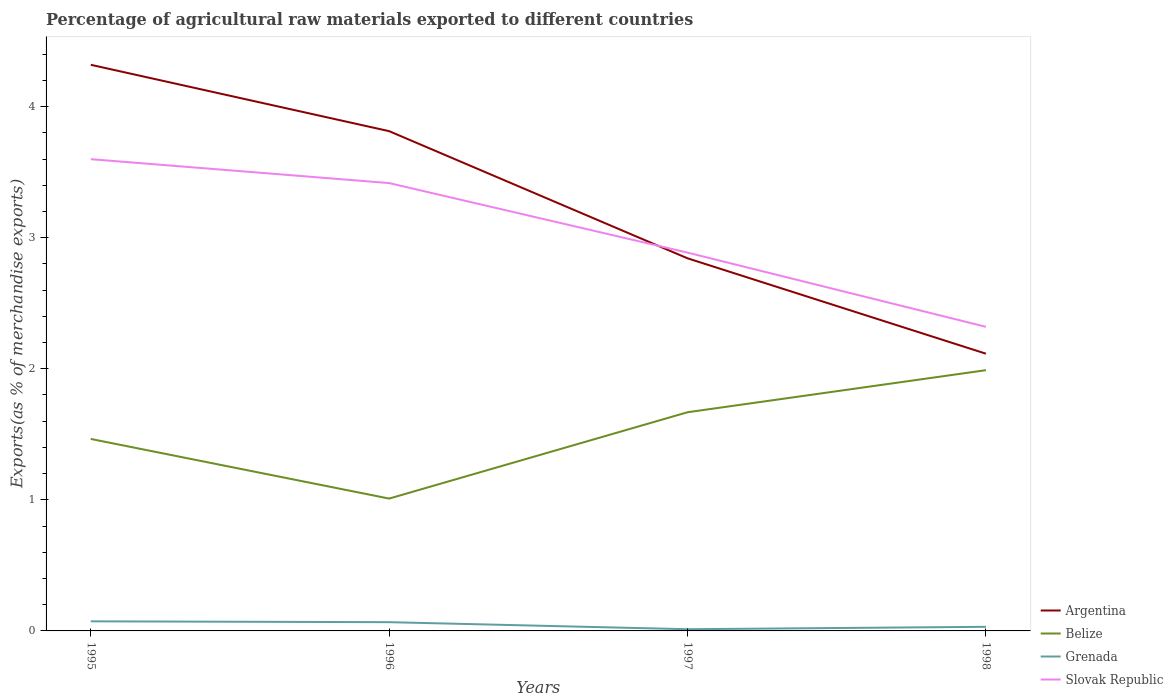How many different coloured lines are there?
Give a very brief answer. 4. Is the number of lines equal to the number of legend labels?
Your answer should be compact. Yes. Across all years, what is the maximum percentage of exports to different countries in Grenada?
Your answer should be compact. 0.01. What is the total percentage of exports to different countries in Belize in the graph?
Your answer should be compact. -0.52. What is the difference between the highest and the second highest percentage of exports to different countries in Argentina?
Your response must be concise. 2.2. What is the difference between the highest and the lowest percentage of exports to different countries in Argentina?
Keep it short and to the point. 2. Is the percentage of exports to different countries in Slovak Republic strictly greater than the percentage of exports to different countries in Argentina over the years?
Make the answer very short. No. How many lines are there?
Make the answer very short. 4. What is the difference between two consecutive major ticks on the Y-axis?
Provide a succinct answer. 1. Does the graph contain grids?
Ensure brevity in your answer.  No. How many legend labels are there?
Offer a terse response. 4. What is the title of the graph?
Make the answer very short. Percentage of agricultural raw materials exported to different countries. What is the label or title of the Y-axis?
Provide a short and direct response. Exports(as % of merchandise exports). What is the Exports(as % of merchandise exports) of Argentina in 1995?
Make the answer very short. 4.32. What is the Exports(as % of merchandise exports) of Belize in 1995?
Your answer should be compact. 1.46. What is the Exports(as % of merchandise exports) in Grenada in 1995?
Offer a terse response. 0.07. What is the Exports(as % of merchandise exports) of Slovak Republic in 1995?
Ensure brevity in your answer.  3.6. What is the Exports(as % of merchandise exports) in Argentina in 1996?
Offer a very short reply. 3.81. What is the Exports(as % of merchandise exports) of Belize in 1996?
Offer a very short reply. 1.01. What is the Exports(as % of merchandise exports) in Grenada in 1996?
Your response must be concise. 0.07. What is the Exports(as % of merchandise exports) of Slovak Republic in 1996?
Ensure brevity in your answer.  3.42. What is the Exports(as % of merchandise exports) in Argentina in 1997?
Offer a terse response. 2.84. What is the Exports(as % of merchandise exports) of Belize in 1997?
Your response must be concise. 1.67. What is the Exports(as % of merchandise exports) of Grenada in 1997?
Provide a succinct answer. 0.01. What is the Exports(as % of merchandise exports) in Slovak Republic in 1997?
Keep it short and to the point. 2.89. What is the Exports(as % of merchandise exports) of Argentina in 1998?
Offer a terse response. 2.11. What is the Exports(as % of merchandise exports) in Belize in 1998?
Give a very brief answer. 1.99. What is the Exports(as % of merchandise exports) in Grenada in 1998?
Provide a succinct answer. 0.03. What is the Exports(as % of merchandise exports) of Slovak Republic in 1998?
Keep it short and to the point. 2.32. Across all years, what is the maximum Exports(as % of merchandise exports) in Argentina?
Your answer should be very brief. 4.32. Across all years, what is the maximum Exports(as % of merchandise exports) in Belize?
Ensure brevity in your answer.  1.99. Across all years, what is the maximum Exports(as % of merchandise exports) of Grenada?
Provide a short and direct response. 0.07. Across all years, what is the maximum Exports(as % of merchandise exports) of Slovak Republic?
Your answer should be very brief. 3.6. Across all years, what is the minimum Exports(as % of merchandise exports) of Argentina?
Keep it short and to the point. 2.11. Across all years, what is the minimum Exports(as % of merchandise exports) in Belize?
Your answer should be very brief. 1.01. Across all years, what is the minimum Exports(as % of merchandise exports) of Grenada?
Ensure brevity in your answer.  0.01. Across all years, what is the minimum Exports(as % of merchandise exports) in Slovak Republic?
Your answer should be compact. 2.32. What is the total Exports(as % of merchandise exports) in Argentina in the graph?
Make the answer very short. 13.09. What is the total Exports(as % of merchandise exports) in Belize in the graph?
Your answer should be compact. 6.13. What is the total Exports(as % of merchandise exports) in Grenada in the graph?
Offer a terse response. 0.18. What is the total Exports(as % of merchandise exports) in Slovak Republic in the graph?
Your answer should be compact. 12.22. What is the difference between the Exports(as % of merchandise exports) in Argentina in 1995 and that in 1996?
Keep it short and to the point. 0.51. What is the difference between the Exports(as % of merchandise exports) in Belize in 1995 and that in 1996?
Make the answer very short. 0.45. What is the difference between the Exports(as % of merchandise exports) of Grenada in 1995 and that in 1996?
Give a very brief answer. 0.01. What is the difference between the Exports(as % of merchandise exports) of Slovak Republic in 1995 and that in 1996?
Keep it short and to the point. 0.18. What is the difference between the Exports(as % of merchandise exports) in Argentina in 1995 and that in 1997?
Ensure brevity in your answer.  1.48. What is the difference between the Exports(as % of merchandise exports) of Belize in 1995 and that in 1997?
Offer a terse response. -0.2. What is the difference between the Exports(as % of merchandise exports) of Grenada in 1995 and that in 1997?
Your answer should be compact. 0.06. What is the difference between the Exports(as % of merchandise exports) in Slovak Republic in 1995 and that in 1997?
Provide a short and direct response. 0.71. What is the difference between the Exports(as % of merchandise exports) of Argentina in 1995 and that in 1998?
Ensure brevity in your answer.  2.2. What is the difference between the Exports(as % of merchandise exports) in Belize in 1995 and that in 1998?
Make the answer very short. -0.52. What is the difference between the Exports(as % of merchandise exports) of Grenada in 1995 and that in 1998?
Provide a succinct answer. 0.04. What is the difference between the Exports(as % of merchandise exports) of Slovak Republic in 1995 and that in 1998?
Offer a terse response. 1.28. What is the difference between the Exports(as % of merchandise exports) of Belize in 1996 and that in 1997?
Give a very brief answer. -0.66. What is the difference between the Exports(as % of merchandise exports) of Grenada in 1996 and that in 1997?
Your answer should be compact. 0.05. What is the difference between the Exports(as % of merchandise exports) in Slovak Republic in 1996 and that in 1997?
Give a very brief answer. 0.53. What is the difference between the Exports(as % of merchandise exports) of Argentina in 1996 and that in 1998?
Keep it short and to the point. 1.7. What is the difference between the Exports(as % of merchandise exports) of Belize in 1996 and that in 1998?
Ensure brevity in your answer.  -0.98. What is the difference between the Exports(as % of merchandise exports) of Grenada in 1996 and that in 1998?
Make the answer very short. 0.04. What is the difference between the Exports(as % of merchandise exports) in Slovak Republic in 1996 and that in 1998?
Offer a very short reply. 1.1. What is the difference between the Exports(as % of merchandise exports) in Argentina in 1997 and that in 1998?
Your response must be concise. 0.73. What is the difference between the Exports(as % of merchandise exports) of Belize in 1997 and that in 1998?
Give a very brief answer. -0.32. What is the difference between the Exports(as % of merchandise exports) in Grenada in 1997 and that in 1998?
Your answer should be compact. -0.02. What is the difference between the Exports(as % of merchandise exports) of Slovak Republic in 1997 and that in 1998?
Provide a short and direct response. 0.57. What is the difference between the Exports(as % of merchandise exports) in Argentina in 1995 and the Exports(as % of merchandise exports) in Belize in 1996?
Offer a very short reply. 3.31. What is the difference between the Exports(as % of merchandise exports) in Argentina in 1995 and the Exports(as % of merchandise exports) in Grenada in 1996?
Make the answer very short. 4.25. What is the difference between the Exports(as % of merchandise exports) of Argentina in 1995 and the Exports(as % of merchandise exports) of Slovak Republic in 1996?
Make the answer very short. 0.9. What is the difference between the Exports(as % of merchandise exports) of Belize in 1995 and the Exports(as % of merchandise exports) of Grenada in 1996?
Make the answer very short. 1.4. What is the difference between the Exports(as % of merchandise exports) of Belize in 1995 and the Exports(as % of merchandise exports) of Slovak Republic in 1996?
Your response must be concise. -1.95. What is the difference between the Exports(as % of merchandise exports) in Grenada in 1995 and the Exports(as % of merchandise exports) in Slovak Republic in 1996?
Your response must be concise. -3.34. What is the difference between the Exports(as % of merchandise exports) in Argentina in 1995 and the Exports(as % of merchandise exports) in Belize in 1997?
Provide a succinct answer. 2.65. What is the difference between the Exports(as % of merchandise exports) in Argentina in 1995 and the Exports(as % of merchandise exports) in Grenada in 1997?
Your answer should be very brief. 4.31. What is the difference between the Exports(as % of merchandise exports) in Argentina in 1995 and the Exports(as % of merchandise exports) in Slovak Republic in 1997?
Ensure brevity in your answer.  1.43. What is the difference between the Exports(as % of merchandise exports) in Belize in 1995 and the Exports(as % of merchandise exports) in Grenada in 1997?
Offer a terse response. 1.45. What is the difference between the Exports(as % of merchandise exports) in Belize in 1995 and the Exports(as % of merchandise exports) in Slovak Republic in 1997?
Provide a succinct answer. -1.42. What is the difference between the Exports(as % of merchandise exports) of Grenada in 1995 and the Exports(as % of merchandise exports) of Slovak Republic in 1997?
Your answer should be very brief. -2.81. What is the difference between the Exports(as % of merchandise exports) in Argentina in 1995 and the Exports(as % of merchandise exports) in Belize in 1998?
Your answer should be compact. 2.33. What is the difference between the Exports(as % of merchandise exports) of Argentina in 1995 and the Exports(as % of merchandise exports) of Grenada in 1998?
Offer a terse response. 4.29. What is the difference between the Exports(as % of merchandise exports) in Argentina in 1995 and the Exports(as % of merchandise exports) in Slovak Republic in 1998?
Your answer should be compact. 2. What is the difference between the Exports(as % of merchandise exports) in Belize in 1995 and the Exports(as % of merchandise exports) in Grenada in 1998?
Provide a succinct answer. 1.43. What is the difference between the Exports(as % of merchandise exports) of Belize in 1995 and the Exports(as % of merchandise exports) of Slovak Republic in 1998?
Provide a succinct answer. -0.86. What is the difference between the Exports(as % of merchandise exports) of Grenada in 1995 and the Exports(as % of merchandise exports) of Slovak Republic in 1998?
Provide a short and direct response. -2.25. What is the difference between the Exports(as % of merchandise exports) in Argentina in 1996 and the Exports(as % of merchandise exports) in Belize in 1997?
Offer a very short reply. 2.14. What is the difference between the Exports(as % of merchandise exports) in Argentina in 1996 and the Exports(as % of merchandise exports) in Grenada in 1997?
Give a very brief answer. 3.8. What is the difference between the Exports(as % of merchandise exports) of Argentina in 1996 and the Exports(as % of merchandise exports) of Slovak Republic in 1997?
Your response must be concise. 0.93. What is the difference between the Exports(as % of merchandise exports) of Belize in 1996 and the Exports(as % of merchandise exports) of Grenada in 1997?
Provide a succinct answer. 1. What is the difference between the Exports(as % of merchandise exports) of Belize in 1996 and the Exports(as % of merchandise exports) of Slovak Republic in 1997?
Keep it short and to the point. -1.88. What is the difference between the Exports(as % of merchandise exports) in Grenada in 1996 and the Exports(as % of merchandise exports) in Slovak Republic in 1997?
Give a very brief answer. -2.82. What is the difference between the Exports(as % of merchandise exports) in Argentina in 1996 and the Exports(as % of merchandise exports) in Belize in 1998?
Keep it short and to the point. 1.82. What is the difference between the Exports(as % of merchandise exports) in Argentina in 1996 and the Exports(as % of merchandise exports) in Grenada in 1998?
Make the answer very short. 3.78. What is the difference between the Exports(as % of merchandise exports) in Argentina in 1996 and the Exports(as % of merchandise exports) in Slovak Republic in 1998?
Ensure brevity in your answer.  1.49. What is the difference between the Exports(as % of merchandise exports) in Belize in 1996 and the Exports(as % of merchandise exports) in Grenada in 1998?
Your answer should be compact. 0.98. What is the difference between the Exports(as % of merchandise exports) in Belize in 1996 and the Exports(as % of merchandise exports) in Slovak Republic in 1998?
Give a very brief answer. -1.31. What is the difference between the Exports(as % of merchandise exports) in Grenada in 1996 and the Exports(as % of merchandise exports) in Slovak Republic in 1998?
Keep it short and to the point. -2.25. What is the difference between the Exports(as % of merchandise exports) in Argentina in 1997 and the Exports(as % of merchandise exports) in Belize in 1998?
Make the answer very short. 0.85. What is the difference between the Exports(as % of merchandise exports) in Argentina in 1997 and the Exports(as % of merchandise exports) in Grenada in 1998?
Provide a short and direct response. 2.81. What is the difference between the Exports(as % of merchandise exports) in Argentina in 1997 and the Exports(as % of merchandise exports) in Slovak Republic in 1998?
Provide a succinct answer. 0.52. What is the difference between the Exports(as % of merchandise exports) in Belize in 1997 and the Exports(as % of merchandise exports) in Grenada in 1998?
Offer a terse response. 1.64. What is the difference between the Exports(as % of merchandise exports) of Belize in 1997 and the Exports(as % of merchandise exports) of Slovak Republic in 1998?
Your answer should be very brief. -0.65. What is the difference between the Exports(as % of merchandise exports) of Grenada in 1997 and the Exports(as % of merchandise exports) of Slovak Republic in 1998?
Offer a terse response. -2.31. What is the average Exports(as % of merchandise exports) of Argentina per year?
Offer a terse response. 3.27. What is the average Exports(as % of merchandise exports) in Belize per year?
Ensure brevity in your answer.  1.53. What is the average Exports(as % of merchandise exports) of Grenada per year?
Your answer should be very brief. 0.05. What is the average Exports(as % of merchandise exports) of Slovak Republic per year?
Keep it short and to the point. 3.06. In the year 1995, what is the difference between the Exports(as % of merchandise exports) of Argentina and Exports(as % of merchandise exports) of Belize?
Give a very brief answer. 2.85. In the year 1995, what is the difference between the Exports(as % of merchandise exports) of Argentina and Exports(as % of merchandise exports) of Grenada?
Make the answer very short. 4.25. In the year 1995, what is the difference between the Exports(as % of merchandise exports) in Argentina and Exports(as % of merchandise exports) in Slovak Republic?
Make the answer very short. 0.72. In the year 1995, what is the difference between the Exports(as % of merchandise exports) in Belize and Exports(as % of merchandise exports) in Grenada?
Your response must be concise. 1.39. In the year 1995, what is the difference between the Exports(as % of merchandise exports) of Belize and Exports(as % of merchandise exports) of Slovak Republic?
Offer a terse response. -2.13. In the year 1995, what is the difference between the Exports(as % of merchandise exports) of Grenada and Exports(as % of merchandise exports) of Slovak Republic?
Provide a succinct answer. -3.53. In the year 1996, what is the difference between the Exports(as % of merchandise exports) of Argentina and Exports(as % of merchandise exports) of Belize?
Ensure brevity in your answer.  2.8. In the year 1996, what is the difference between the Exports(as % of merchandise exports) in Argentina and Exports(as % of merchandise exports) in Grenada?
Offer a very short reply. 3.75. In the year 1996, what is the difference between the Exports(as % of merchandise exports) in Argentina and Exports(as % of merchandise exports) in Slovak Republic?
Your answer should be compact. 0.4. In the year 1996, what is the difference between the Exports(as % of merchandise exports) in Belize and Exports(as % of merchandise exports) in Grenada?
Your answer should be compact. 0.94. In the year 1996, what is the difference between the Exports(as % of merchandise exports) in Belize and Exports(as % of merchandise exports) in Slovak Republic?
Your answer should be very brief. -2.41. In the year 1996, what is the difference between the Exports(as % of merchandise exports) of Grenada and Exports(as % of merchandise exports) of Slovak Republic?
Offer a terse response. -3.35. In the year 1997, what is the difference between the Exports(as % of merchandise exports) in Argentina and Exports(as % of merchandise exports) in Belize?
Offer a terse response. 1.17. In the year 1997, what is the difference between the Exports(as % of merchandise exports) of Argentina and Exports(as % of merchandise exports) of Grenada?
Your response must be concise. 2.83. In the year 1997, what is the difference between the Exports(as % of merchandise exports) of Argentina and Exports(as % of merchandise exports) of Slovak Republic?
Your answer should be very brief. -0.04. In the year 1997, what is the difference between the Exports(as % of merchandise exports) of Belize and Exports(as % of merchandise exports) of Grenada?
Offer a very short reply. 1.66. In the year 1997, what is the difference between the Exports(as % of merchandise exports) in Belize and Exports(as % of merchandise exports) in Slovak Republic?
Provide a succinct answer. -1.22. In the year 1997, what is the difference between the Exports(as % of merchandise exports) in Grenada and Exports(as % of merchandise exports) in Slovak Republic?
Give a very brief answer. -2.87. In the year 1998, what is the difference between the Exports(as % of merchandise exports) of Argentina and Exports(as % of merchandise exports) of Belize?
Your answer should be very brief. 0.13. In the year 1998, what is the difference between the Exports(as % of merchandise exports) in Argentina and Exports(as % of merchandise exports) in Grenada?
Make the answer very short. 2.08. In the year 1998, what is the difference between the Exports(as % of merchandise exports) in Argentina and Exports(as % of merchandise exports) in Slovak Republic?
Your response must be concise. -0.2. In the year 1998, what is the difference between the Exports(as % of merchandise exports) of Belize and Exports(as % of merchandise exports) of Grenada?
Provide a short and direct response. 1.96. In the year 1998, what is the difference between the Exports(as % of merchandise exports) in Belize and Exports(as % of merchandise exports) in Slovak Republic?
Make the answer very short. -0.33. In the year 1998, what is the difference between the Exports(as % of merchandise exports) in Grenada and Exports(as % of merchandise exports) in Slovak Republic?
Your response must be concise. -2.29. What is the ratio of the Exports(as % of merchandise exports) in Argentina in 1995 to that in 1996?
Your answer should be compact. 1.13. What is the ratio of the Exports(as % of merchandise exports) in Belize in 1995 to that in 1996?
Offer a very short reply. 1.45. What is the ratio of the Exports(as % of merchandise exports) in Grenada in 1995 to that in 1996?
Your response must be concise. 1.1. What is the ratio of the Exports(as % of merchandise exports) in Slovak Republic in 1995 to that in 1996?
Your answer should be very brief. 1.05. What is the ratio of the Exports(as % of merchandise exports) of Argentina in 1995 to that in 1997?
Your answer should be very brief. 1.52. What is the ratio of the Exports(as % of merchandise exports) in Belize in 1995 to that in 1997?
Provide a succinct answer. 0.88. What is the ratio of the Exports(as % of merchandise exports) of Grenada in 1995 to that in 1997?
Make the answer very short. 5.61. What is the ratio of the Exports(as % of merchandise exports) in Slovak Republic in 1995 to that in 1997?
Your answer should be very brief. 1.25. What is the ratio of the Exports(as % of merchandise exports) of Argentina in 1995 to that in 1998?
Offer a very short reply. 2.04. What is the ratio of the Exports(as % of merchandise exports) in Belize in 1995 to that in 1998?
Give a very brief answer. 0.74. What is the ratio of the Exports(as % of merchandise exports) of Grenada in 1995 to that in 1998?
Provide a succinct answer. 2.33. What is the ratio of the Exports(as % of merchandise exports) of Slovak Republic in 1995 to that in 1998?
Your response must be concise. 1.55. What is the ratio of the Exports(as % of merchandise exports) in Argentina in 1996 to that in 1997?
Give a very brief answer. 1.34. What is the ratio of the Exports(as % of merchandise exports) of Belize in 1996 to that in 1997?
Your response must be concise. 0.61. What is the ratio of the Exports(as % of merchandise exports) of Grenada in 1996 to that in 1997?
Your answer should be compact. 5.12. What is the ratio of the Exports(as % of merchandise exports) of Slovak Republic in 1996 to that in 1997?
Your answer should be very brief. 1.18. What is the ratio of the Exports(as % of merchandise exports) of Argentina in 1996 to that in 1998?
Provide a short and direct response. 1.8. What is the ratio of the Exports(as % of merchandise exports) in Belize in 1996 to that in 1998?
Provide a succinct answer. 0.51. What is the ratio of the Exports(as % of merchandise exports) in Grenada in 1996 to that in 1998?
Your response must be concise. 2.13. What is the ratio of the Exports(as % of merchandise exports) in Slovak Republic in 1996 to that in 1998?
Make the answer very short. 1.47. What is the ratio of the Exports(as % of merchandise exports) in Argentina in 1997 to that in 1998?
Offer a very short reply. 1.34. What is the ratio of the Exports(as % of merchandise exports) of Belize in 1997 to that in 1998?
Your answer should be very brief. 0.84. What is the ratio of the Exports(as % of merchandise exports) in Grenada in 1997 to that in 1998?
Keep it short and to the point. 0.42. What is the ratio of the Exports(as % of merchandise exports) of Slovak Republic in 1997 to that in 1998?
Your answer should be compact. 1.24. What is the difference between the highest and the second highest Exports(as % of merchandise exports) of Argentina?
Offer a terse response. 0.51. What is the difference between the highest and the second highest Exports(as % of merchandise exports) in Belize?
Make the answer very short. 0.32. What is the difference between the highest and the second highest Exports(as % of merchandise exports) of Grenada?
Ensure brevity in your answer.  0.01. What is the difference between the highest and the second highest Exports(as % of merchandise exports) of Slovak Republic?
Your response must be concise. 0.18. What is the difference between the highest and the lowest Exports(as % of merchandise exports) in Argentina?
Provide a succinct answer. 2.2. What is the difference between the highest and the lowest Exports(as % of merchandise exports) in Belize?
Keep it short and to the point. 0.98. What is the difference between the highest and the lowest Exports(as % of merchandise exports) of Grenada?
Your response must be concise. 0.06. What is the difference between the highest and the lowest Exports(as % of merchandise exports) in Slovak Republic?
Your answer should be very brief. 1.28. 